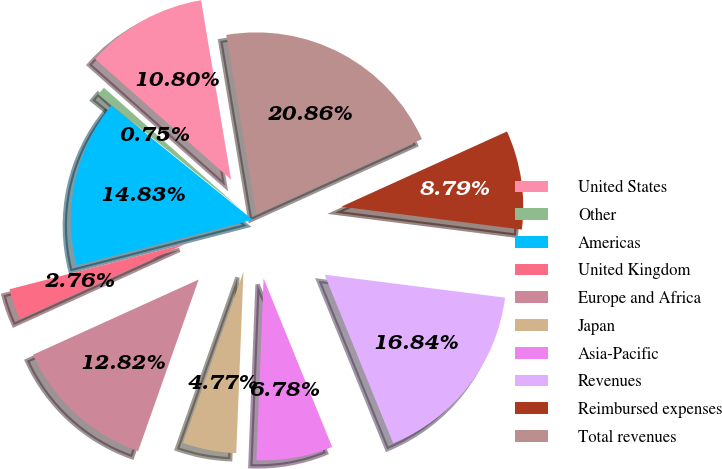<chart> <loc_0><loc_0><loc_500><loc_500><pie_chart><fcel>United States<fcel>Other<fcel>Americas<fcel>United Kingdom<fcel>Europe and Africa<fcel>Japan<fcel>Asia-Pacific<fcel>Revenues<fcel>Reimbursed expenses<fcel>Total revenues<nl><fcel>10.8%<fcel>0.75%<fcel>14.83%<fcel>2.76%<fcel>12.82%<fcel>4.77%<fcel>6.78%<fcel>16.84%<fcel>8.79%<fcel>20.86%<nl></chart> 